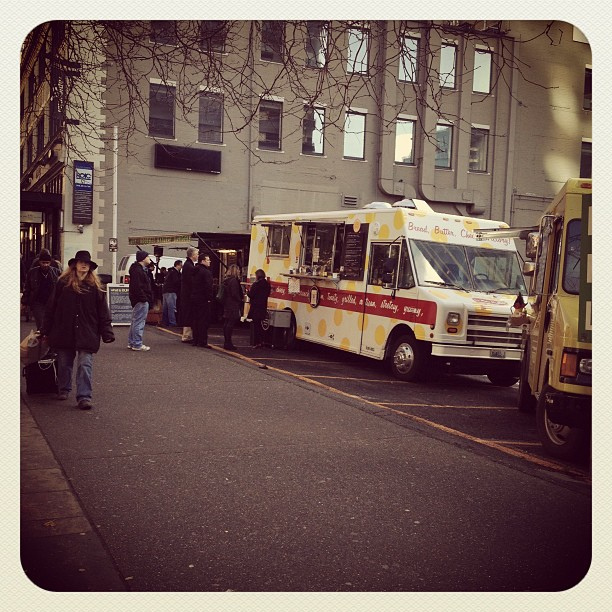How many people can you see? From what is visible in the image, there appear to be at least 6 individuals congregated around the food trucks, likely enjoying the casual outdoor dining atmosphere typical of such venues. 